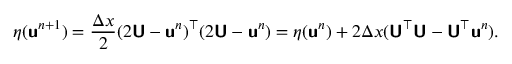<formula> <loc_0><loc_0><loc_500><loc_500>\eta ( u ^ { n + 1 } ) = \frac { \Delta x } { 2 } ( 2 U - u ^ { n } ) ^ { \top } ( 2 U - u ^ { n } ) = \eta ( u ^ { n } ) + 2 \Delta x ( U ^ { \top } U - U ^ { \top } u ^ { n } ) .</formula> 